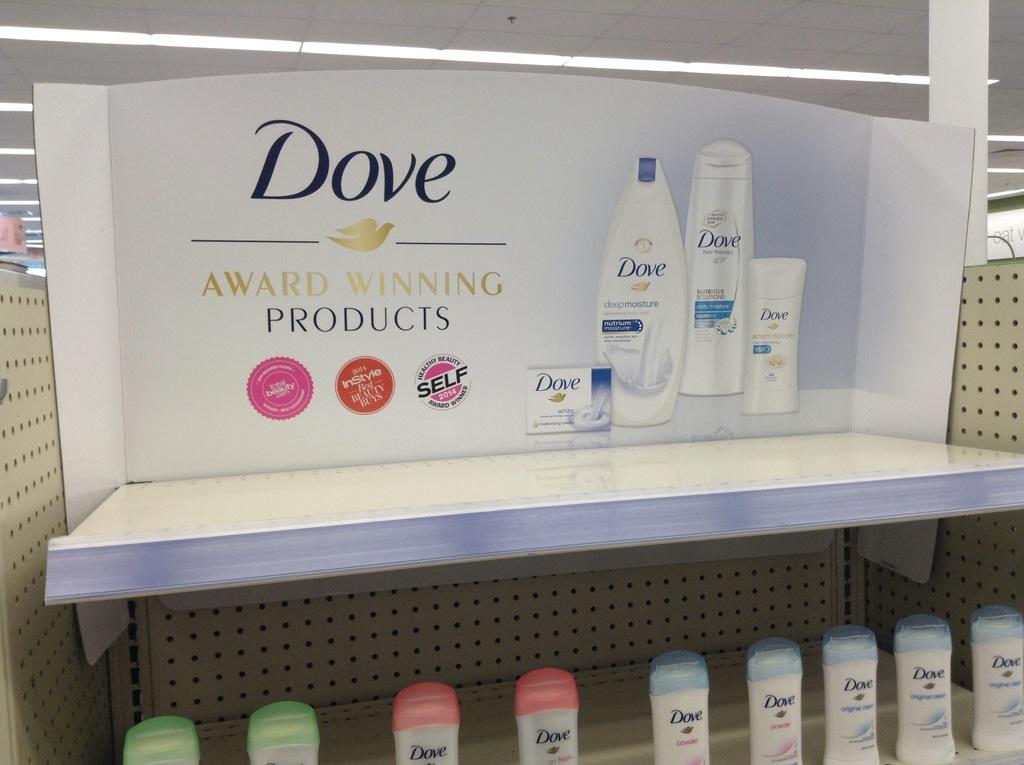What brand are these products?
Offer a terse response. Dove. Have these products won awards?
Provide a succinct answer. Yes. 